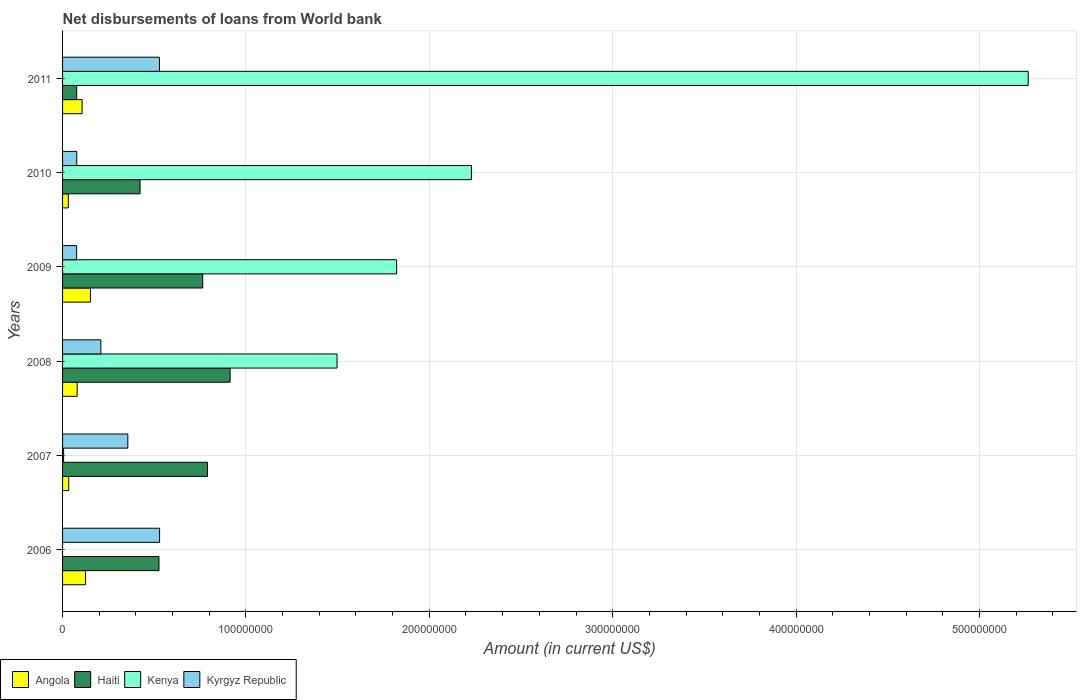Are the number of bars per tick equal to the number of legend labels?
Keep it short and to the point. No. How many bars are there on the 2nd tick from the top?
Your answer should be compact. 4. How many bars are there on the 1st tick from the bottom?
Provide a succinct answer. 3. What is the label of the 6th group of bars from the top?
Give a very brief answer. 2006. What is the amount of loan disbursed from World Bank in Haiti in 2011?
Keep it short and to the point. 7.70e+06. Across all years, what is the maximum amount of loan disbursed from World Bank in Kyrgyz Republic?
Give a very brief answer. 5.29e+07. Across all years, what is the minimum amount of loan disbursed from World Bank in Angola?
Provide a succinct answer. 3.14e+06. In which year was the amount of loan disbursed from World Bank in Kenya maximum?
Your answer should be very brief. 2011. What is the total amount of loan disbursed from World Bank in Kyrgyz Republic in the graph?
Your response must be concise. 1.78e+08. What is the difference between the amount of loan disbursed from World Bank in Kyrgyz Republic in 2006 and that in 2008?
Ensure brevity in your answer.  3.20e+07. What is the difference between the amount of loan disbursed from World Bank in Angola in 2010 and the amount of loan disbursed from World Bank in Haiti in 2007?
Offer a terse response. -7.59e+07. What is the average amount of loan disbursed from World Bank in Haiti per year?
Provide a short and direct response. 5.82e+07. In the year 2009, what is the difference between the amount of loan disbursed from World Bank in Haiti and amount of loan disbursed from World Bank in Kenya?
Provide a succinct answer. -1.06e+08. What is the ratio of the amount of loan disbursed from World Bank in Haiti in 2009 to that in 2010?
Your response must be concise. 1.81. Is the difference between the amount of loan disbursed from World Bank in Haiti in 2007 and 2009 greater than the difference between the amount of loan disbursed from World Bank in Kenya in 2007 and 2009?
Make the answer very short. Yes. What is the difference between the highest and the second highest amount of loan disbursed from World Bank in Angola?
Offer a very short reply. 2.68e+06. What is the difference between the highest and the lowest amount of loan disbursed from World Bank in Kyrgyz Republic?
Your answer should be compact. 4.53e+07. Is it the case that in every year, the sum of the amount of loan disbursed from World Bank in Haiti and amount of loan disbursed from World Bank in Kyrgyz Republic is greater than the sum of amount of loan disbursed from World Bank in Kenya and amount of loan disbursed from World Bank in Angola?
Give a very brief answer. No. How many years are there in the graph?
Give a very brief answer. 6. Are the values on the major ticks of X-axis written in scientific E-notation?
Offer a very short reply. No. Does the graph contain any zero values?
Provide a short and direct response. Yes. Does the graph contain grids?
Ensure brevity in your answer.  Yes. How many legend labels are there?
Your response must be concise. 4. How are the legend labels stacked?
Your answer should be very brief. Horizontal. What is the title of the graph?
Give a very brief answer. Net disbursements of loans from World bank. Does "Denmark" appear as one of the legend labels in the graph?
Provide a short and direct response. No. What is the label or title of the Y-axis?
Your response must be concise. Years. What is the Amount (in current US$) in Angola in 2006?
Your answer should be compact. 1.25e+07. What is the Amount (in current US$) in Haiti in 2006?
Your response must be concise. 5.26e+07. What is the Amount (in current US$) in Kyrgyz Republic in 2006?
Make the answer very short. 5.29e+07. What is the Amount (in current US$) of Angola in 2007?
Provide a succinct answer. 3.36e+06. What is the Amount (in current US$) in Haiti in 2007?
Offer a terse response. 7.90e+07. What is the Amount (in current US$) of Kenya in 2007?
Your answer should be very brief. 5.68e+05. What is the Amount (in current US$) of Kyrgyz Republic in 2007?
Provide a short and direct response. 3.56e+07. What is the Amount (in current US$) in Angola in 2008?
Give a very brief answer. 7.97e+06. What is the Amount (in current US$) of Haiti in 2008?
Your answer should be compact. 9.14e+07. What is the Amount (in current US$) in Kenya in 2008?
Provide a succinct answer. 1.50e+08. What is the Amount (in current US$) of Kyrgyz Republic in 2008?
Make the answer very short. 2.09e+07. What is the Amount (in current US$) of Angola in 2009?
Provide a succinct answer. 1.52e+07. What is the Amount (in current US$) in Haiti in 2009?
Give a very brief answer. 7.64e+07. What is the Amount (in current US$) of Kenya in 2009?
Your answer should be compact. 1.82e+08. What is the Amount (in current US$) of Kyrgyz Republic in 2009?
Give a very brief answer. 7.66e+06. What is the Amount (in current US$) in Angola in 2010?
Your answer should be very brief. 3.14e+06. What is the Amount (in current US$) of Haiti in 2010?
Keep it short and to the point. 4.23e+07. What is the Amount (in current US$) of Kenya in 2010?
Provide a short and direct response. 2.23e+08. What is the Amount (in current US$) of Kyrgyz Republic in 2010?
Your response must be concise. 7.73e+06. What is the Amount (in current US$) in Angola in 2011?
Provide a succinct answer. 1.07e+07. What is the Amount (in current US$) in Haiti in 2011?
Your response must be concise. 7.70e+06. What is the Amount (in current US$) in Kenya in 2011?
Keep it short and to the point. 5.27e+08. What is the Amount (in current US$) in Kyrgyz Republic in 2011?
Your response must be concise. 5.28e+07. Across all years, what is the maximum Amount (in current US$) in Angola?
Provide a succinct answer. 1.52e+07. Across all years, what is the maximum Amount (in current US$) in Haiti?
Make the answer very short. 9.14e+07. Across all years, what is the maximum Amount (in current US$) of Kenya?
Provide a succinct answer. 5.27e+08. Across all years, what is the maximum Amount (in current US$) of Kyrgyz Republic?
Make the answer very short. 5.29e+07. Across all years, what is the minimum Amount (in current US$) in Angola?
Offer a very short reply. 3.14e+06. Across all years, what is the minimum Amount (in current US$) of Haiti?
Give a very brief answer. 7.70e+06. Across all years, what is the minimum Amount (in current US$) in Kyrgyz Republic?
Make the answer very short. 7.66e+06. What is the total Amount (in current US$) of Angola in the graph?
Give a very brief answer. 5.29e+07. What is the total Amount (in current US$) of Haiti in the graph?
Your answer should be compact. 3.49e+08. What is the total Amount (in current US$) in Kenya in the graph?
Offer a very short reply. 1.08e+09. What is the total Amount (in current US$) in Kyrgyz Republic in the graph?
Offer a very short reply. 1.78e+08. What is the difference between the Amount (in current US$) of Angola in 2006 and that in 2007?
Keep it short and to the point. 9.18e+06. What is the difference between the Amount (in current US$) of Haiti in 2006 and that in 2007?
Ensure brevity in your answer.  -2.64e+07. What is the difference between the Amount (in current US$) in Kyrgyz Republic in 2006 and that in 2007?
Offer a terse response. 1.73e+07. What is the difference between the Amount (in current US$) in Angola in 2006 and that in 2008?
Give a very brief answer. 4.57e+06. What is the difference between the Amount (in current US$) in Haiti in 2006 and that in 2008?
Keep it short and to the point. -3.88e+07. What is the difference between the Amount (in current US$) of Kyrgyz Republic in 2006 and that in 2008?
Your answer should be very brief. 3.20e+07. What is the difference between the Amount (in current US$) in Angola in 2006 and that in 2009?
Offer a terse response. -2.68e+06. What is the difference between the Amount (in current US$) in Haiti in 2006 and that in 2009?
Offer a terse response. -2.38e+07. What is the difference between the Amount (in current US$) of Kyrgyz Republic in 2006 and that in 2009?
Offer a very short reply. 4.53e+07. What is the difference between the Amount (in current US$) in Angola in 2006 and that in 2010?
Keep it short and to the point. 9.40e+06. What is the difference between the Amount (in current US$) in Haiti in 2006 and that in 2010?
Keep it short and to the point. 1.03e+07. What is the difference between the Amount (in current US$) of Kyrgyz Republic in 2006 and that in 2010?
Make the answer very short. 4.52e+07. What is the difference between the Amount (in current US$) of Angola in 2006 and that in 2011?
Provide a short and direct response. 1.88e+06. What is the difference between the Amount (in current US$) of Haiti in 2006 and that in 2011?
Make the answer very short. 4.49e+07. What is the difference between the Amount (in current US$) in Kyrgyz Republic in 2006 and that in 2011?
Provide a short and direct response. 7.80e+04. What is the difference between the Amount (in current US$) of Angola in 2007 and that in 2008?
Your answer should be compact. -4.61e+06. What is the difference between the Amount (in current US$) of Haiti in 2007 and that in 2008?
Your answer should be compact. -1.23e+07. What is the difference between the Amount (in current US$) in Kenya in 2007 and that in 2008?
Keep it short and to the point. -1.49e+08. What is the difference between the Amount (in current US$) in Kyrgyz Republic in 2007 and that in 2008?
Ensure brevity in your answer.  1.47e+07. What is the difference between the Amount (in current US$) in Angola in 2007 and that in 2009?
Your response must be concise. -1.19e+07. What is the difference between the Amount (in current US$) in Haiti in 2007 and that in 2009?
Provide a succinct answer. 2.60e+06. What is the difference between the Amount (in current US$) of Kenya in 2007 and that in 2009?
Offer a terse response. -1.82e+08. What is the difference between the Amount (in current US$) in Kyrgyz Republic in 2007 and that in 2009?
Provide a succinct answer. 2.79e+07. What is the difference between the Amount (in current US$) of Angola in 2007 and that in 2010?
Your response must be concise. 2.22e+05. What is the difference between the Amount (in current US$) of Haiti in 2007 and that in 2010?
Your answer should be compact. 3.68e+07. What is the difference between the Amount (in current US$) in Kenya in 2007 and that in 2010?
Your answer should be compact. -2.22e+08. What is the difference between the Amount (in current US$) in Kyrgyz Republic in 2007 and that in 2010?
Your answer should be very brief. 2.79e+07. What is the difference between the Amount (in current US$) in Angola in 2007 and that in 2011?
Your answer should be very brief. -7.30e+06. What is the difference between the Amount (in current US$) of Haiti in 2007 and that in 2011?
Your response must be concise. 7.13e+07. What is the difference between the Amount (in current US$) of Kenya in 2007 and that in 2011?
Offer a very short reply. -5.26e+08. What is the difference between the Amount (in current US$) in Kyrgyz Republic in 2007 and that in 2011?
Your response must be concise. -1.72e+07. What is the difference between the Amount (in current US$) of Angola in 2008 and that in 2009?
Offer a terse response. -7.24e+06. What is the difference between the Amount (in current US$) of Haiti in 2008 and that in 2009?
Keep it short and to the point. 1.49e+07. What is the difference between the Amount (in current US$) of Kenya in 2008 and that in 2009?
Your answer should be very brief. -3.25e+07. What is the difference between the Amount (in current US$) in Kyrgyz Republic in 2008 and that in 2009?
Your answer should be very brief. 1.32e+07. What is the difference between the Amount (in current US$) in Angola in 2008 and that in 2010?
Your answer should be very brief. 4.83e+06. What is the difference between the Amount (in current US$) of Haiti in 2008 and that in 2010?
Offer a terse response. 4.91e+07. What is the difference between the Amount (in current US$) in Kenya in 2008 and that in 2010?
Offer a terse response. -7.33e+07. What is the difference between the Amount (in current US$) of Kyrgyz Republic in 2008 and that in 2010?
Keep it short and to the point. 1.32e+07. What is the difference between the Amount (in current US$) in Angola in 2008 and that in 2011?
Give a very brief answer. -2.69e+06. What is the difference between the Amount (in current US$) of Haiti in 2008 and that in 2011?
Give a very brief answer. 8.37e+07. What is the difference between the Amount (in current US$) in Kenya in 2008 and that in 2011?
Provide a succinct answer. -3.77e+08. What is the difference between the Amount (in current US$) in Kyrgyz Republic in 2008 and that in 2011?
Ensure brevity in your answer.  -3.19e+07. What is the difference between the Amount (in current US$) in Angola in 2009 and that in 2010?
Offer a very short reply. 1.21e+07. What is the difference between the Amount (in current US$) in Haiti in 2009 and that in 2010?
Ensure brevity in your answer.  3.42e+07. What is the difference between the Amount (in current US$) of Kenya in 2009 and that in 2010?
Make the answer very short. -4.08e+07. What is the difference between the Amount (in current US$) of Kyrgyz Republic in 2009 and that in 2010?
Your answer should be very brief. -7.20e+04. What is the difference between the Amount (in current US$) of Angola in 2009 and that in 2011?
Make the answer very short. 4.55e+06. What is the difference between the Amount (in current US$) of Haiti in 2009 and that in 2011?
Keep it short and to the point. 6.87e+07. What is the difference between the Amount (in current US$) of Kenya in 2009 and that in 2011?
Offer a very short reply. -3.44e+08. What is the difference between the Amount (in current US$) in Kyrgyz Republic in 2009 and that in 2011?
Provide a succinct answer. -4.52e+07. What is the difference between the Amount (in current US$) in Angola in 2010 and that in 2011?
Keep it short and to the point. -7.52e+06. What is the difference between the Amount (in current US$) in Haiti in 2010 and that in 2011?
Offer a terse response. 3.46e+07. What is the difference between the Amount (in current US$) of Kenya in 2010 and that in 2011?
Provide a succinct answer. -3.04e+08. What is the difference between the Amount (in current US$) in Kyrgyz Republic in 2010 and that in 2011?
Ensure brevity in your answer.  -4.51e+07. What is the difference between the Amount (in current US$) in Angola in 2006 and the Amount (in current US$) in Haiti in 2007?
Your answer should be compact. -6.65e+07. What is the difference between the Amount (in current US$) of Angola in 2006 and the Amount (in current US$) of Kenya in 2007?
Keep it short and to the point. 1.20e+07. What is the difference between the Amount (in current US$) of Angola in 2006 and the Amount (in current US$) of Kyrgyz Republic in 2007?
Make the answer very short. -2.31e+07. What is the difference between the Amount (in current US$) in Haiti in 2006 and the Amount (in current US$) in Kenya in 2007?
Give a very brief answer. 5.20e+07. What is the difference between the Amount (in current US$) in Haiti in 2006 and the Amount (in current US$) in Kyrgyz Republic in 2007?
Make the answer very short. 1.70e+07. What is the difference between the Amount (in current US$) in Angola in 2006 and the Amount (in current US$) in Haiti in 2008?
Offer a very short reply. -7.88e+07. What is the difference between the Amount (in current US$) in Angola in 2006 and the Amount (in current US$) in Kenya in 2008?
Provide a succinct answer. -1.37e+08. What is the difference between the Amount (in current US$) in Angola in 2006 and the Amount (in current US$) in Kyrgyz Republic in 2008?
Ensure brevity in your answer.  -8.35e+06. What is the difference between the Amount (in current US$) in Haiti in 2006 and the Amount (in current US$) in Kenya in 2008?
Your response must be concise. -9.71e+07. What is the difference between the Amount (in current US$) of Haiti in 2006 and the Amount (in current US$) of Kyrgyz Republic in 2008?
Your answer should be compact. 3.17e+07. What is the difference between the Amount (in current US$) in Angola in 2006 and the Amount (in current US$) in Haiti in 2009?
Give a very brief answer. -6.39e+07. What is the difference between the Amount (in current US$) of Angola in 2006 and the Amount (in current US$) of Kenya in 2009?
Offer a terse response. -1.70e+08. What is the difference between the Amount (in current US$) in Angola in 2006 and the Amount (in current US$) in Kyrgyz Republic in 2009?
Your response must be concise. 4.88e+06. What is the difference between the Amount (in current US$) in Haiti in 2006 and the Amount (in current US$) in Kenya in 2009?
Give a very brief answer. -1.30e+08. What is the difference between the Amount (in current US$) in Haiti in 2006 and the Amount (in current US$) in Kyrgyz Republic in 2009?
Provide a succinct answer. 4.49e+07. What is the difference between the Amount (in current US$) of Angola in 2006 and the Amount (in current US$) of Haiti in 2010?
Provide a short and direct response. -2.97e+07. What is the difference between the Amount (in current US$) in Angola in 2006 and the Amount (in current US$) in Kenya in 2010?
Give a very brief answer. -2.10e+08. What is the difference between the Amount (in current US$) in Angola in 2006 and the Amount (in current US$) in Kyrgyz Republic in 2010?
Provide a short and direct response. 4.81e+06. What is the difference between the Amount (in current US$) in Haiti in 2006 and the Amount (in current US$) in Kenya in 2010?
Give a very brief answer. -1.70e+08. What is the difference between the Amount (in current US$) in Haiti in 2006 and the Amount (in current US$) in Kyrgyz Republic in 2010?
Keep it short and to the point. 4.49e+07. What is the difference between the Amount (in current US$) of Angola in 2006 and the Amount (in current US$) of Haiti in 2011?
Your answer should be very brief. 4.83e+06. What is the difference between the Amount (in current US$) in Angola in 2006 and the Amount (in current US$) in Kenya in 2011?
Provide a short and direct response. -5.14e+08. What is the difference between the Amount (in current US$) in Angola in 2006 and the Amount (in current US$) in Kyrgyz Republic in 2011?
Your answer should be very brief. -4.03e+07. What is the difference between the Amount (in current US$) in Haiti in 2006 and the Amount (in current US$) in Kenya in 2011?
Your response must be concise. -4.74e+08. What is the difference between the Amount (in current US$) of Haiti in 2006 and the Amount (in current US$) of Kyrgyz Republic in 2011?
Your response must be concise. -2.52e+05. What is the difference between the Amount (in current US$) in Angola in 2007 and the Amount (in current US$) in Haiti in 2008?
Provide a short and direct response. -8.80e+07. What is the difference between the Amount (in current US$) in Angola in 2007 and the Amount (in current US$) in Kenya in 2008?
Give a very brief answer. -1.46e+08. What is the difference between the Amount (in current US$) in Angola in 2007 and the Amount (in current US$) in Kyrgyz Republic in 2008?
Provide a short and direct response. -1.75e+07. What is the difference between the Amount (in current US$) in Haiti in 2007 and the Amount (in current US$) in Kenya in 2008?
Your response must be concise. -7.07e+07. What is the difference between the Amount (in current US$) in Haiti in 2007 and the Amount (in current US$) in Kyrgyz Republic in 2008?
Ensure brevity in your answer.  5.81e+07. What is the difference between the Amount (in current US$) in Kenya in 2007 and the Amount (in current US$) in Kyrgyz Republic in 2008?
Give a very brief answer. -2.03e+07. What is the difference between the Amount (in current US$) in Angola in 2007 and the Amount (in current US$) in Haiti in 2009?
Your response must be concise. -7.31e+07. What is the difference between the Amount (in current US$) of Angola in 2007 and the Amount (in current US$) of Kenya in 2009?
Offer a very short reply. -1.79e+08. What is the difference between the Amount (in current US$) of Angola in 2007 and the Amount (in current US$) of Kyrgyz Republic in 2009?
Your answer should be very brief. -4.30e+06. What is the difference between the Amount (in current US$) of Haiti in 2007 and the Amount (in current US$) of Kenya in 2009?
Your answer should be very brief. -1.03e+08. What is the difference between the Amount (in current US$) in Haiti in 2007 and the Amount (in current US$) in Kyrgyz Republic in 2009?
Your response must be concise. 7.14e+07. What is the difference between the Amount (in current US$) of Kenya in 2007 and the Amount (in current US$) of Kyrgyz Republic in 2009?
Offer a very short reply. -7.09e+06. What is the difference between the Amount (in current US$) of Angola in 2007 and the Amount (in current US$) of Haiti in 2010?
Offer a terse response. -3.89e+07. What is the difference between the Amount (in current US$) of Angola in 2007 and the Amount (in current US$) of Kenya in 2010?
Make the answer very short. -2.20e+08. What is the difference between the Amount (in current US$) of Angola in 2007 and the Amount (in current US$) of Kyrgyz Republic in 2010?
Your answer should be compact. -4.37e+06. What is the difference between the Amount (in current US$) of Haiti in 2007 and the Amount (in current US$) of Kenya in 2010?
Offer a terse response. -1.44e+08. What is the difference between the Amount (in current US$) of Haiti in 2007 and the Amount (in current US$) of Kyrgyz Republic in 2010?
Make the answer very short. 7.13e+07. What is the difference between the Amount (in current US$) of Kenya in 2007 and the Amount (in current US$) of Kyrgyz Republic in 2010?
Make the answer very short. -7.16e+06. What is the difference between the Amount (in current US$) in Angola in 2007 and the Amount (in current US$) in Haiti in 2011?
Provide a short and direct response. -4.34e+06. What is the difference between the Amount (in current US$) of Angola in 2007 and the Amount (in current US$) of Kenya in 2011?
Keep it short and to the point. -5.23e+08. What is the difference between the Amount (in current US$) of Angola in 2007 and the Amount (in current US$) of Kyrgyz Republic in 2011?
Your response must be concise. -4.95e+07. What is the difference between the Amount (in current US$) in Haiti in 2007 and the Amount (in current US$) in Kenya in 2011?
Ensure brevity in your answer.  -4.48e+08. What is the difference between the Amount (in current US$) in Haiti in 2007 and the Amount (in current US$) in Kyrgyz Republic in 2011?
Your answer should be compact. 2.62e+07. What is the difference between the Amount (in current US$) of Kenya in 2007 and the Amount (in current US$) of Kyrgyz Republic in 2011?
Give a very brief answer. -5.23e+07. What is the difference between the Amount (in current US$) of Angola in 2008 and the Amount (in current US$) of Haiti in 2009?
Give a very brief answer. -6.85e+07. What is the difference between the Amount (in current US$) of Angola in 2008 and the Amount (in current US$) of Kenya in 2009?
Offer a terse response. -1.74e+08. What is the difference between the Amount (in current US$) of Angola in 2008 and the Amount (in current US$) of Kyrgyz Republic in 2009?
Provide a succinct answer. 3.14e+05. What is the difference between the Amount (in current US$) in Haiti in 2008 and the Amount (in current US$) in Kenya in 2009?
Make the answer very short. -9.08e+07. What is the difference between the Amount (in current US$) in Haiti in 2008 and the Amount (in current US$) in Kyrgyz Republic in 2009?
Your response must be concise. 8.37e+07. What is the difference between the Amount (in current US$) in Kenya in 2008 and the Amount (in current US$) in Kyrgyz Republic in 2009?
Your response must be concise. 1.42e+08. What is the difference between the Amount (in current US$) of Angola in 2008 and the Amount (in current US$) of Haiti in 2010?
Your answer should be very brief. -3.43e+07. What is the difference between the Amount (in current US$) in Angola in 2008 and the Amount (in current US$) in Kenya in 2010?
Offer a very short reply. -2.15e+08. What is the difference between the Amount (in current US$) of Angola in 2008 and the Amount (in current US$) of Kyrgyz Republic in 2010?
Keep it short and to the point. 2.42e+05. What is the difference between the Amount (in current US$) in Haiti in 2008 and the Amount (in current US$) in Kenya in 2010?
Make the answer very short. -1.32e+08. What is the difference between the Amount (in current US$) in Haiti in 2008 and the Amount (in current US$) in Kyrgyz Republic in 2010?
Provide a succinct answer. 8.36e+07. What is the difference between the Amount (in current US$) of Kenya in 2008 and the Amount (in current US$) of Kyrgyz Republic in 2010?
Offer a very short reply. 1.42e+08. What is the difference between the Amount (in current US$) in Angola in 2008 and the Amount (in current US$) in Haiti in 2011?
Ensure brevity in your answer.  2.65e+05. What is the difference between the Amount (in current US$) in Angola in 2008 and the Amount (in current US$) in Kenya in 2011?
Provide a short and direct response. -5.19e+08. What is the difference between the Amount (in current US$) of Angola in 2008 and the Amount (in current US$) of Kyrgyz Republic in 2011?
Offer a terse response. -4.49e+07. What is the difference between the Amount (in current US$) in Haiti in 2008 and the Amount (in current US$) in Kenya in 2011?
Your response must be concise. -4.35e+08. What is the difference between the Amount (in current US$) of Haiti in 2008 and the Amount (in current US$) of Kyrgyz Republic in 2011?
Keep it short and to the point. 3.85e+07. What is the difference between the Amount (in current US$) in Kenya in 2008 and the Amount (in current US$) in Kyrgyz Republic in 2011?
Offer a terse response. 9.68e+07. What is the difference between the Amount (in current US$) in Angola in 2009 and the Amount (in current US$) in Haiti in 2010?
Provide a succinct answer. -2.71e+07. What is the difference between the Amount (in current US$) in Angola in 2009 and the Amount (in current US$) in Kenya in 2010?
Provide a succinct answer. -2.08e+08. What is the difference between the Amount (in current US$) in Angola in 2009 and the Amount (in current US$) in Kyrgyz Republic in 2010?
Provide a succinct answer. 7.48e+06. What is the difference between the Amount (in current US$) in Haiti in 2009 and the Amount (in current US$) in Kenya in 2010?
Ensure brevity in your answer.  -1.47e+08. What is the difference between the Amount (in current US$) of Haiti in 2009 and the Amount (in current US$) of Kyrgyz Republic in 2010?
Your response must be concise. 6.87e+07. What is the difference between the Amount (in current US$) of Kenya in 2009 and the Amount (in current US$) of Kyrgyz Republic in 2010?
Give a very brief answer. 1.74e+08. What is the difference between the Amount (in current US$) of Angola in 2009 and the Amount (in current US$) of Haiti in 2011?
Keep it short and to the point. 7.51e+06. What is the difference between the Amount (in current US$) in Angola in 2009 and the Amount (in current US$) in Kenya in 2011?
Offer a terse response. -5.11e+08. What is the difference between the Amount (in current US$) of Angola in 2009 and the Amount (in current US$) of Kyrgyz Republic in 2011?
Your answer should be very brief. -3.76e+07. What is the difference between the Amount (in current US$) of Haiti in 2009 and the Amount (in current US$) of Kenya in 2011?
Provide a short and direct response. -4.50e+08. What is the difference between the Amount (in current US$) in Haiti in 2009 and the Amount (in current US$) in Kyrgyz Republic in 2011?
Your response must be concise. 2.36e+07. What is the difference between the Amount (in current US$) in Kenya in 2009 and the Amount (in current US$) in Kyrgyz Republic in 2011?
Your answer should be compact. 1.29e+08. What is the difference between the Amount (in current US$) in Angola in 2010 and the Amount (in current US$) in Haiti in 2011?
Your answer should be compact. -4.57e+06. What is the difference between the Amount (in current US$) of Angola in 2010 and the Amount (in current US$) of Kenya in 2011?
Keep it short and to the point. -5.23e+08. What is the difference between the Amount (in current US$) of Angola in 2010 and the Amount (in current US$) of Kyrgyz Republic in 2011?
Give a very brief answer. -4.97e+07. What is the difference between the Amount (in current US$) of Haiti in 2010 and the Amount (in current US$) of Kenya in 2011?
Offer a terse response. -4.84e+08. What is the difference between the Amount (in current US$) in Haiti in 2010 and the Amount (in current US$) in Kyrgyz Republic in 2011?
Your response must be concise. -1.06e+07. What is the difference between the Amount (in current US$) in Kenya in 2010 and the Amount (in current US$) in Kyrgyz Republic in 2011?
Offer a terse response. 1.70e+08. What is the average Amount (in current US$) in Angola per year?
Your answer should be very brief. 8.81e+06. What is the average Amount (in current US$) in Haiti per year?
Provide a short and direct response. 5.82e+07. What is the average Amount (in current US$) in Kenya per year?
Provide a short and direct response. 1.80e+08. What is the average Amount (in current US$) in Kyrgyz Republic per year?
Give a very brief answer. 2.96e+07. In the year 2006, what is the difference between the Amount (in current US$) in Angola and Amount (in current US$) in Haiti?
Provide a short and direct response. -4.00e+07. In the year 2006, what is the difference between the Amount (in current US$) of Angola and Amount (in current US$) of Kyrgyz Republic?
Provide a short and direct response. -4.04e+07. In the year 2006, what is the difference between the Amount (in current US$) of Haiti and Amount (in current US$) of Kyrgyz Republic?
Your answer should be very brief. -3.30e+05. In the year 2007, what is the difference between the Amount (in current US$) of Angola and Amount (in current US$) of Haiti?
Keep it short and to the point. -7.57e+07. In the year 2007, what is the difference between the Amount (in current US$) in Angola and Amount (in current US$) in Kenya?
Offer a very short reply. 2.79e+06. In the year 2007, what is the difference between the Amount (in current US$) of Angola and Amount (in current US$) of Kyrgyz Republic?
Offer a terse response. -3.22e+07. In the year 2007, what is the difference between the Amount (in current US$) in Haiti and Amount (in current US$) in Kenya?
Make the answer very short. 7.85e+07. In the year 2007, what is the difference between the Amount (in current US$) in Haiti and Amount (in current US$) in Kyrgyz Republic?
Your answer should be very brief. 4.34e+07. In the year 2007, what is the difference between the Amount (in current US$) in Kenya and Amount (in current US$) in Kyrgyz Republic?
Keep it short and to the point. -3.50e+07. In the year 2008, what is the difference between the Amount (in current US$) of Angola and Amount (in current US$) of Haiti?
Offer a very short reply. -8.34e+07. In the year 2008, what is the difference between the Amount (in current US$) in Angola and Amount (in current US$) in Kenya?
Your answer should be compact. -1.42e+08. In the year 2008, what is the difference between the Amount (in current US$) in Angola and Amount (in current US$) in Kyrgyz Republic?
Your answer should be compact. -1.29e+07. In the year 2008, what is the difference between the Amount (in current US$) of Haiti and Amount (in current US$) of Kenya?
Offer a terse response. -5.83e+07. In the year 2008, what is the difference between the Amount (in current US$) of Haiti and Amount (in current US$) of Kyrgyz Republic?
Keep it short and to the point. 7.05e+07. In the year 2008, what is the difference between the Amount (in current US$) of Kenya and Amount (in current US$) of Kyrgyz Republic?
Offer a very short reply. 1.29e+08. In the year 2009, what is the difference between the Amount (in current US$) in Angola and Amount (in current US$) in Haiti?
Provide a short and direct response. -6.12e+07. In the year 2009, what is the difference between the Amount (in current US$) in Angola and Amount (in current US$) in Kenya?
Provide a short and direct response. -1.67e+08. In the year 2009, what is the difference between the Amount (in current US$) of Angola and Amount (in current US$) of Kyrgyz Republic?
Make the answer very short. 7.56e+06. In the year 2009, what is the difference between the Amount (in current US$) of Haiti and Amount (in current US$) of Kenya?
Offer a terse response. -1.06e+08. In the year 2009, what is the difference between the Amount (in current US$) of Haiti and Amount (in current US$) of Kyrgyz Republic?
Your response must be concise. 6.88e+07. In the year 2009, what is the difference between the Amount (in current US$) in Kenya and Amount (in current US$) in Kyrgyz Republic?
Your response must be concise. 1.75e+08. In the year 2010, what is the difference between the Amount (in current US$) of Angola and Amount (in current US$) of Haiti?
Keep it short and to the point. -3.91e+07. In the year 2010, what is the difference between the Amount (in current US$) in Angola and Amount (in current US$) in Kenya?
Ensure brevity in your answer.  -2.20e+08. In the year 2010, what is the difference between the Amount (in current US$) of Angola and Amount (in current US$) of Kyrgyz Republic?
Keep it short and to the point. -4.59e+06. In the year 2010, what is the difference between the Amount (in current US$) of Haiti and Amount (in current US$) of Kenya?
Your answer should be very brief. -1.81e+08. In the year 2010, what is the difference between the Amount (in current US$) in Haiti and Amount (in current US$) in Kyrgyz Republic?
Ensure brevity in your answer.  3.45e+07. In the year 2010, what is the difference between the Amount (in current US$) of Kenya and Amount (in current US$) of Kyrgyz Republic?
Provide a short and direct response. 2.15e+08. In the year 2011, what is the difference between the Amount (in current US$) in Angola and Amount (in current US$) in Haiti?
Offer a very short reply. 2.96e+06. In the year 2011, what is the difference between the Amount (in current US$) in Angola and Amount (in current US$) in Kenya?
Your answer should be compact. -5.16e+08. In the year 2011, what is the difference between the Amount (in current US$) in Angola and Amount (in current US$) in Kyrgyz Republic?
Keep it short and to the point. -4.22e+07. In the year 2011, what is the difference between the Amount (in current US$) in Haiti and Amount (in current US$) in Kenya?
Offer a very short reply. -5.19e+08. In the year 2011, what is the difference between the Amount (in current US$) of Haiti and Amount (in current US$) of Kyrgyz Republic?
Provide a short and direct response. -4.51e+07. In the year 2011, what is the difference between the Amount (in current US$) in Kenya and Amount (in current US$) in Kyrgyz Republic?
Your answer should be compact. 4.74e+08. What is the ratio of the Amount (in current US$) in Angola in 2006 to that in 2007?
Offer a very short reply. 3.73. What is the ratio of the Amount (in current US$) of Haiti in 2006 to that in 2007?
Provide a succinct answer. 0.67. What is the ratio of the Amount (in current US$) in Kyrgyz Republic in 2006 to that in 2007?
Offer a very short reply. 1.49. What is the ratio of the Amount (in current US$) of Angola in 2006 to that in 2008?
Offer a terse response. 1.57. What is the ratio of the Amount (in current US$) of Haiti in 2006 to that in 2008?
Your answer should be compact. 0.58. What is the ratio of the Amount (in current US$) in Kyrgyz Republic in 2006 to that in 2008?
Provide a succinct answer. 2.53. What is the ratio of the Amount (in current US$) in Angola in 2006 to that in 2009?
Ensure brevity in your answer.  0.82. What is the ratio of the Amount (in current US$) of Haiti in 2006 to that in 2009?
Provide a short and direct response. 0.69. What is the ratio of the Amount (in current US$) in Kyrgyz Republic in 2006 to that in 2009?
Ensure brevity in your answer.  6.91. What is the ratio of the Amount (in current US$) of Angola in 2006 to that in 2010?
Your response must be concise. 4. What is the ratio of the Amount (in current US$) in Haiti in 2006 to that in 2010?
Keep it short and to the point. 1.24. What is the ratio of the Amount (in current US$) in Kyrgyz Republic in 2006 to that in 2010?
Your answer should be very brief. 6.85. What is the ratio of the Amount (in current US$) in Angola in 2006 to that in 2011?
Provide a short and direct response. 1.18. What is the ratio of the Amount (in current US$) in Haiti in 2006 to that in 2011?
Your answer should be very brief. 6.83. What is the ratio of the Amount (in current US$) in Kyrgyz Republic in 2006 to that in 2011?
Offer a very short reply. 1. What is the ratio of the Amount (in current US$) in Angola in 2007 to that in 2008?
Make the answer very short. 0.42. What is the ratio of the Amount (in current US$) in Haiti in 2007 to that in 2008?
Provide a succinct answer. 0.86. What is the ratio of the Amount (in current US$) in Kenya in 2007 to that in 2008?
Give a very brief answer. 0. What is the ratio of the Amount (in current US$) of Kyrgyz Republic in 2007 to that in 2008?
Your response must be concise. 1.7. What is the ratio of the Amount (in current US$) of Angola in 2007 to that in 2009?
Offer a very short reply. 0.22. What is the ratio of the Amount (in current US$) of Haiti in 2007 to that in 2009?
Your answer should be very brief. 1.03. What is the ratio of the Amount (in current US$) in Kenya in 2007 to that in 2009?
Make the answer very short. 0. What is the ratio of the Amount (in current US$) in Kyrgyz Republic in 2007 to that in 2009?
Your answer should be compact. 4.65. What is the ratio of the Amount (in current US$) in Angola in 2007 to that in 2010?
Keep it short and to the point. 1.07. What is the ratio of the Amount (in current US$) in Haiti in 2007 to that in 2010?
Provide a succinct answer. 1.87. What is the ratio of the Amount (in current US$) in Kenya in 2007 to that in 2010?
Provide a succinct answer. 0. What is the ratio of the Amount (in current US$) of Kyrgyz Republic in 2007 to that in 2010?
Offer a terse response. 4.61. What is the ratio of the Amount (in current US$) in Angola in 2007 to that in 2011?
Keep it short and to the point. 0.32. What is the ratio of the Amount (in current US$) of Haiti in 2007 to that in 2011?
Offer a very short reply. 10.26. What is the ratio of the Amount (in current US$) in Kenya in 2007 to that in 2011?
Your response must be concise. 0. What is the ratio of the Amount (in current US$) in Kyrgyz Republic in 2007 to that in 2011?
Your response must be concise. 0.67. What is the ratio of the Amount (in current US$) of Angola in 2008 to that in 2009?
Ensure brevity in your answer.  0.52. What is the ratio of the Amount (in current US$) of Haiti in 2008 to that in 2009?
Your response must be concise. 1.2. What is the ratio of the Amount (in current US$) of Kenya in 2008 to that in 2009?
Make the answer very short. 0.82. What is the ratio of the Amount (in current US$) in Kyrgyz Republic in 2008 to that in 2009?
Provide a short and direct response. 2.73. What is the ratio of the Amount (in current US$) of Angola in 2008 to that in 2010?
Offer a very short reply. 2.54. What is the ratio of the Amount (in current US$) in Haiti in 2008 to that in 2010?
Your answer should be very brief. 2.16. What is the ratio of the Amount (in current US$) in Kenya in 2008 to that in 2010?
Provide a short and direct response. 0.67. What is the ratio of the Amount (in current US$) in Kyrgyz Republic in 2008 to that in 2010?
Make the answer very short. 2.7. What is the ratio of the Amount (in current US$) in Angola in 2008 to that in 2011?
Give a very brief answer. 0.75. What is the ratio of the Amount (in current US$) in Haiti in 2008 to that in 2011?
Offer a terse response. 11.86. What is the ratio of the Amount (in current US$) in Kenya in 2008 to that in 2011?
Ensure brevity in your answer.  0.28. What is the ratio of the Amount (in current US$) of Kyrgyz Republic in 2008 to that in 2011?
Ensure brevity in your answer.  0.4. What is the ratio of the Amount (in current US$) in Angola in 2009 to that in 2010?
Make the answer very short. 4.85. What is the ratio of the Amount (in current US$) in Haiti in 2009 to that in 2010?
Offer a very short reply. 1.81. What is the ratio of the Amount (in current US$) in Kenya in 2009 to that in 2010?
Provide a succinct answer. 0.82. What is the ratio of the Amount (in current US$) in Angola in 2009 to that in 2011?
Keep it short and to the point. 1.43. What is the ratio of the Amount (in current US$) of Haiti in 2009 to that in 2011?
Ensure brevity in your answer.  9.92. What is the ratio of the Amount (in current US$) of Kenya in 2009 to that in 2011?
Keep it short and to the point. 0.35. What is the ratio of the Amount (in current US$) in Kyrgyz Republic in 2009 to that in 2011?
Ensure brevity in your answer.  0.14. What is the ratio of the Amount (in current US$) of Angola in 2010 to that in 2011?
Offer a very short reply. 0.29. What is the ratio of the Amount (in current US$) in Haiti in 2010 to that in 2011?
Offer a very short reply. 5.49. What is the ratio of the Amount (in current US$) in Kenya in 2010 to that in 2011?
Give a very brief answer. 0.42. What is the ratio of the Amount (in current US$) in Kyrgyz Republic in 2010 to that in 2011?
Make the answer very short. 0.15. What is the difference between the highest and the second highest Amount (in current US$) of Angola?
Offer a terse response. 2.68e+06. What is the difference between the highest and the second highest Amount (in current US$) in Haiti?
Offer a very short reply. 1.23e+07. What is the difference between the highest and the second highest Amount (in current US$) in Kenya?
Your answer should be compact. 3.04e+08. What is the difference between the highest and the second highest Amount (in current US$) of Kyrgyz Republic?
Offer a very short reply. 7.80e+04. What is the difference between the highest and the lowest Amount (in current US$) in Angola?
Provide a short and direct response. 1.21e+07. What is the difference between the highest and the lowest Amount (in current US$) of Haiti?
Give a very brief answer. 8.37e+07. What is the difference between the highest and the lowest Amount (in current US$) of Kenya?
Offer a very short reply. 5.27e+08. What is the difference between the highest and the lowest Amount (in current US$) of Kyrgyz Republic?
Offer a very short reply. 4.53e+07. 